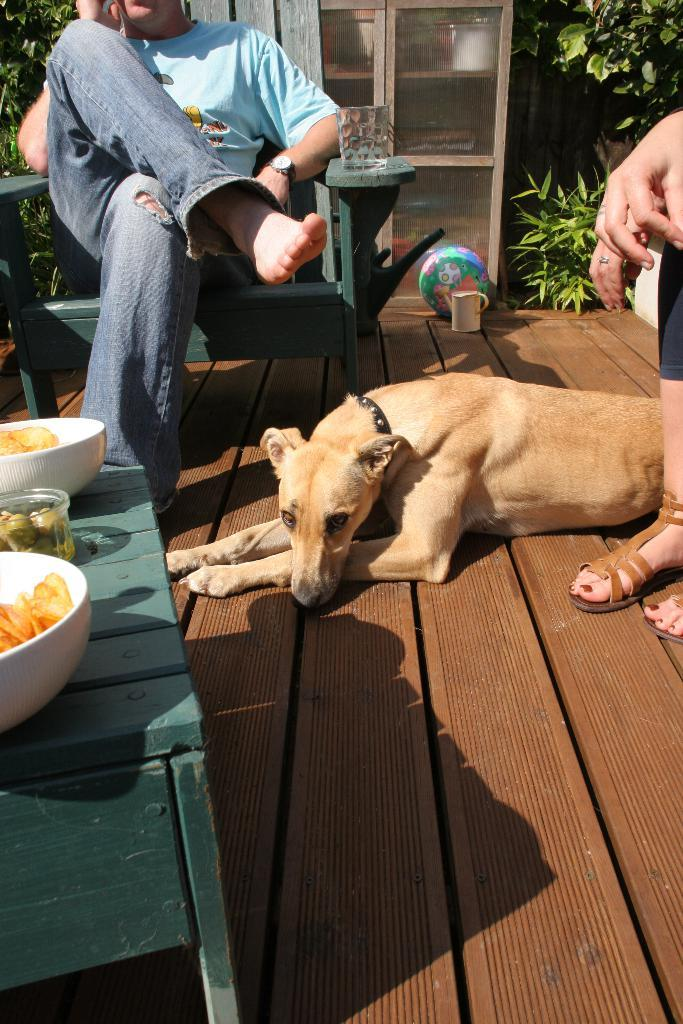What animal is on the floor in the image? There is a dog on the floor in the image. How many people are present in the image? There are two people sitting on either side of the dog. What is the primary piece of furniture in the image? There is a table in the image. What can be found on the table in the left corner? There are eatables placed on the table in the left corner. What type of jeans is the dog wearing in the image? There is no mention of the dog wearing jeans in the image. Dogs do not wear clothing like humans do. 